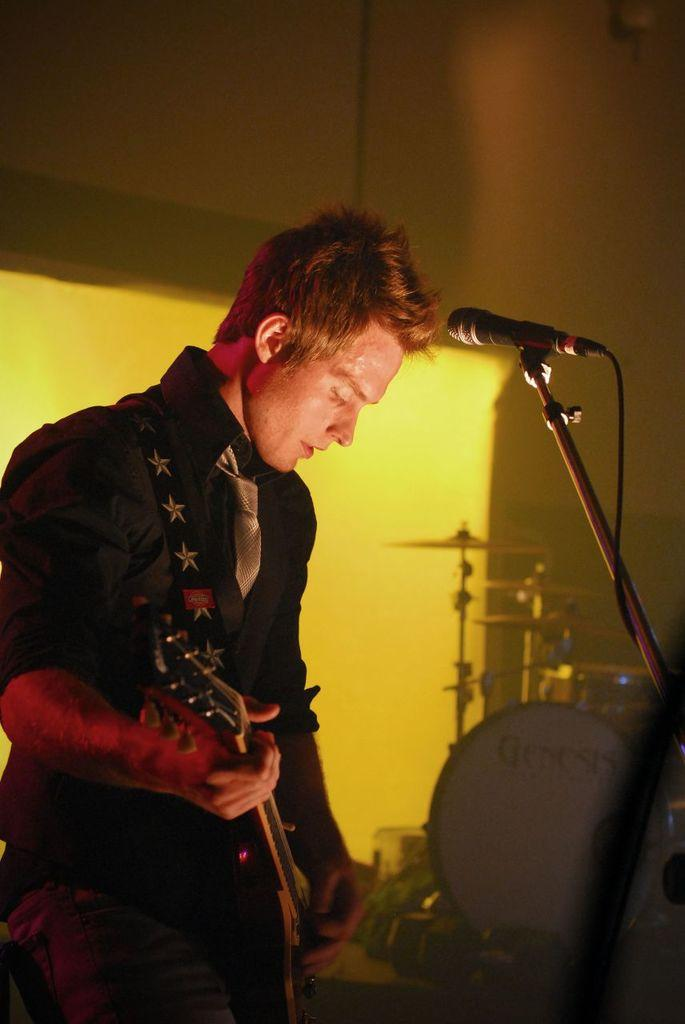Who is present in the image? There is a man in the image. Where is the man located? The man is in a room. What is the man holding in the image? The man is holding a guitar. What object is present for amplifying sound in the image? There is a microphone in the image. What color is the wall behind the man? The background of the man is a yellow wall. What type of scent can be detected in the room in the image? There is no information about any scent in the image, so it cannot be determined. --- Facts: 1. There is a dog in the image. 2. The dog is on a leash. 3. There is a person walking the dog. 4. The person is holding a bag. 5. The background of the image is a park. Absurd Topics: parrot, bicycle, ocean Conversation: What type of animal is present in the image? There is a dog in the image. How is the dog being controlled in the image? The dog is on a leash in the image. Who is accompanying the dog in the image? There is a person walking the dog in the image. What is the person holding while walking the dog? The person is holding a bag in the image. What type of location is visible in the background of the image? The background of the image is a park. Reasoning: Let's think step by step in order to produce the conversation. We start by identifying the main subject in the image, which is the dog. Then, we expand the conversation to include details about the dog's leash, the person walking the dog, and the presence of a bag. We also mention the background location, which is a park, to provide more context about the setting. Absurd Question/Answer: What type of bicycle can be seen in the image? There is no bicycle present in the image. 